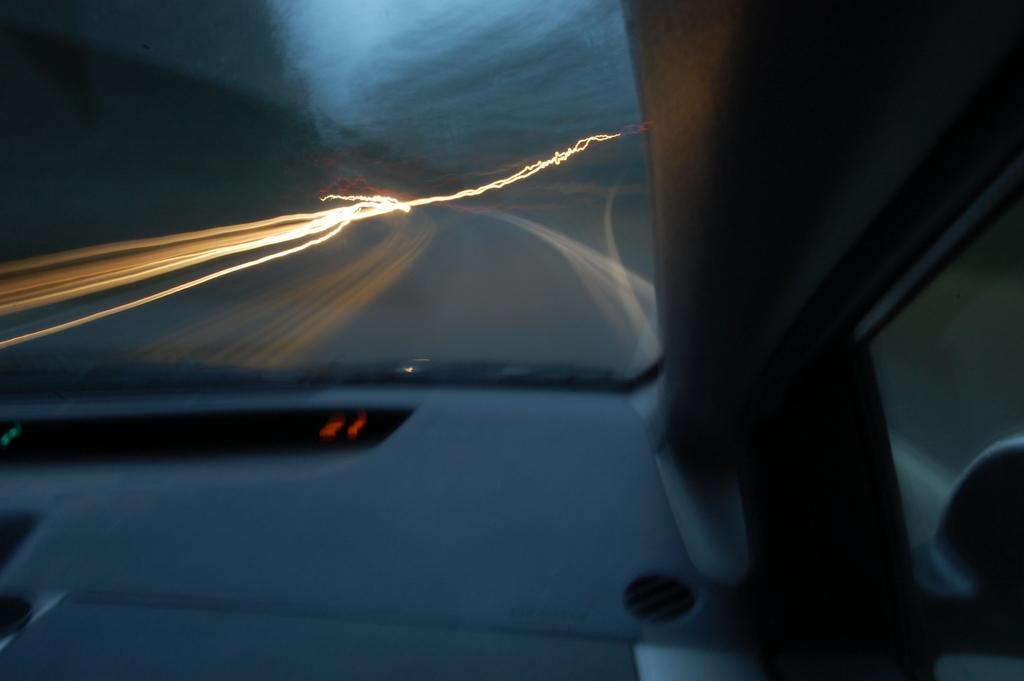What is the main subject of the image? There is a vehicle in the image. What color is the vehicle? The vehicle is white. Can you describe the background of the image? The background of the image is blurred. How many trees are visible in the image? There are no trees visible in the image; it only features a white vehicle with a blurred background. 